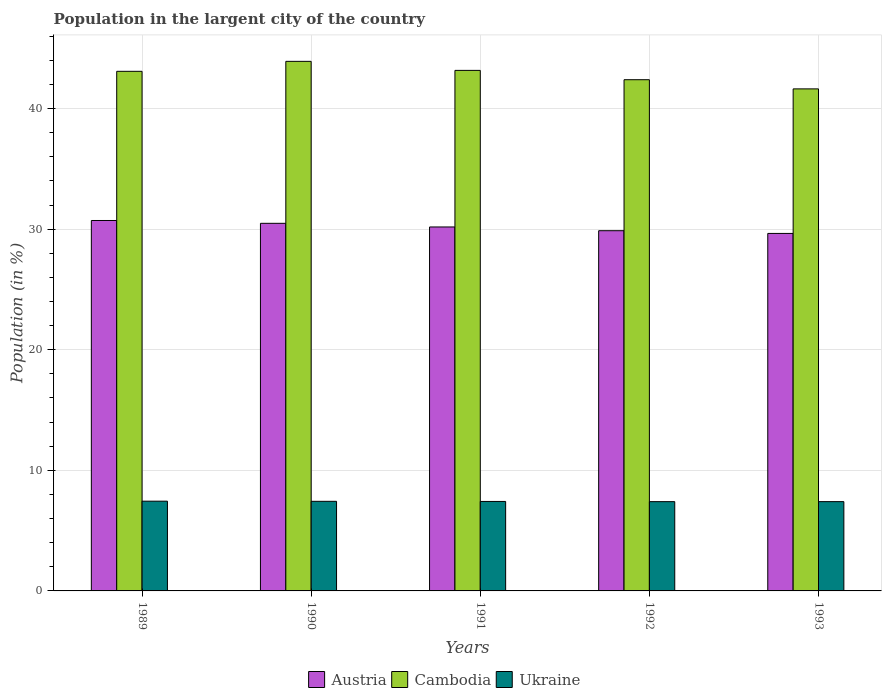How many different coloured bars are there?
Offer a very short reply. 3. Are the number of bars per tick equal to the number of legend labels?
Your answer should be compact. Yes. How many bars are there on the 4th tick from the left?
Your response must be concise. 3. What is the label of the 5th group of bars from the left?
Provide a succinct answer. 1993. What is the percentage of population in the largent city in Austria in 1991?
Offer a terse response. 30.18. Across all years, what is the maximum percentage of population in the largent city in Ukraine?
Provide a short and direct response. 7.44. Across all years, what is the minimum percentage of population in the largent city in Ukraine?
Make the answer very short. 7.4. In which year was the percentage of population in the largent city in Austria maximum?
Give a very brief answer. 1989. What is the total percentage of population in the largent city in Cambodia in the graph?
Give a very brief answer. 214.18. What is the difference between the percentage of population in the largent city in Ukraine in 1990 and that in 1991?
Provide a succinct answer. 0.01. What is the difference between the percentage of population in the largent city in Ukraine in 1992 and the percentage of population in the largent city in Cambodia in 1993?
Give a very brief answer. -34.23. What is the average percentage of population in the largent city in Ukraine per year?
Ensure brevity in your answer.  7.42. In the year 1993, what is the difference between the percentage of population in the largent city in Ukraine and percentage of population in the largent city in Austria?
Your answer should be very brief. -22.24. What is the ratio of the percentage of population in the largent city in Austria in 1989 to that in 1993?
Provide a succinct answer. 1.04. Is the percentage of population in the largent city in Ukraine in 1989 less than that in 1990?
Keep it short and to the point. No. What is the difference between the highest and the second highest percentage of population in the largent city in Cambodia?
Offer a very short reply. 0.75. What is the difference between the highest and the lowest percentage of population in the largent city in Ukraine?
Your answer should be compact. 0.04. In how many years, is the percentage of population in the largent city in Cambodia greater than the average percentage of population in the largent city in Cambodia taken over all years?
Provide a short and direct response. 3. Is the sum of the percentage of population in the largent city in Austria in 1989 and 1992 greater than the maximum percentage of population in the largent city in Ukraine across all years?
Keep it short and to the point. Yes. What does the 2nd bar from the left in 1989 represents?
Provide a succinct answer. Cambodia. What does the 3rd bar from the right in 1989 represents?
Provide a succinct answer. Austria. How many bars are there?
Give a very brief answer. 15. How many years are there in the graph?
Ensure brevity in your answer.  5. Does the graph contain any zero values?
Offer a terse response. No. Where does the legend appear in the graph?
Offer a terse response. Bottom center. How many legend labels are there?
Provide a short and direct response. 3. How are the legend labels stacked?
Provide a succinct answer. Horizontal. What is the title of the graph?
Provide a succinct answer. Population in the largent city of the country. Does "Canada" appear as one of the legend labels in the graph?
Your response must be concise. No. What is the label or title of the Y-axis?
Ensure brevity in your answer.  Population (in %). What is the Population (in %) in Austria in 1989?
Your answer should be very brief. 30.72. What is the Population (in %) of Cambodia in 1989?
Your answer should be very brief. 43.09. What is the Population (in %) in Ukraine in 1989?
Make the answer very short. 7.44. What is the Population (in %) in Austria in 1990?
Ensure brevity in your answer.  30.48. What is the Population (in %) of Cambodia in 1990?
Make the answer very short. 43.91. What is the Population (in %) in Ukraine in 1990?
Make the answer very short. 7.43. What is the Population (in %) of Austria in 1991?
Your answer should be compact. 30.18. What is the Population (in %) in Cambodia in 1991?
Your response must be concise. 43.16. What is the Population (in %) in Ukraine in 1991?
Give a very brief answer. 7.42. What is the Population (in %) in Austria in 1992?
Provide a short and direct response. 29.87. What is the Population (in %) of Cambodia in 1992?
Keep it short and to the point. 42.39. What is the Population (in %) of Ukraine in 1992?
Your response must be concise. 7.4. What is the Population (in %) in Austria in 1993?
Keep it short and to the point. 29.64. What is the Population (in %) of Cambodia in 1993?
Your response must be concise. 41.63. What is the Population (in %) in Ukraine in 1993?
Your response must be concise. 7.4. Across all years, what is the maximum Population (in %) of Austria?
Give a very brief answer. 30.72. Across all years, what is the maximum Population (in %) of Cambodia?
Provide a short and direct response. 43.91. Across all years, what is the maximum Population (in %) of Ukraine?
Offer a terse response. 7.44. Across all years, what is the minimum Population (in %) in Austria?
Offer a very short reply. 29.64. Across all years, what is the minimum Population (in %) in Cambodia?
Provide a succinct answer. 41.63. Across all years, what is the minimum Population (in %) of Ukraine?
Your response must be concise. 7.4. What is the total Population (in %) of Austria in the graph?
Offer a very short reply. 150.89. What is the total Population (in %) of Cambodia in the graph?
Provide a succinct answer. 214.18. What is the total Population (in %) of Ukraine in the graph?
Give a very brief answer. 37.1. What is the difference between the Population (in %) in Austria in 1989 and that in 1990?
Offer a very short reply. 0.23. What is the difference between the Population (in %) in Cambodia in 1989 and that in 1990?
Provide a short and direct response. -0.83. What is the difference between the Population (in %) in Ukraine in 1989 and that in 1990?
Offer a terse response. 0.01. What is the difference between the Population (in %) of Austria in 1989 and that in 1991?
Provide a succinct answer. 0.54. What is the difference between the Population (in %) of Cambodia in 1989 and that in 1991?
Your answer should be compact. -0.08. What is the difference between the Population (in %) of Ukraine in 1989 and that in 1991?
Keep it short and to the point. 0.02. What is the difference between the Population (in %) of Austria in 1989 and that in 1992?
Ensure brevity in your answer.  0.85. What is the difference between the Population (in %) of Cambodia in 1989 and that in 1992?
Give a very brief answer. 0.7. What is the difference between the Population (in %) of Ukraine in 1989 and that in 1992?
Keep it short and to the point. 0.04. What is the difference between the Population (in %) of Austria in 1989 and that in 1993?
Make the answer very short. 1.07. What is the difference between the Population (in %) in Cambodia in 1989 and that in 1993?
Keep it short and to the point. 1.46. What is the difference between the Population (in %) of Ukraine in 1989 and that in 1993?
Ensure brevity in your answer.  0.04. What is the difference between the Population (in %) in Austria in 1990 and that in 1991?
Give a very brief answer. 0.3. What is the difference between the Population (in %) in Cambodia in 1990 and that in 1991?
Ensure brevity in your answer.  0.75. What is the difference between the Population (in %) of Ukraine in 1990 and that in 1991?
Give a very brief answer. 0.01. What is the difference between the Population (in %) in Austria in 1990 and that in 1992?
Offer a very short reply. 0.61. What is the difference between the Population (in %) in Cambodia in 1990 and that in 1992?
Your answer should be very brief. 1.52. What is the difference between the Population (in %) of Ukraine in 1990 and that in 1992?
Provide a succinct answer. 0.03. What is the difference between the Population (in %) of Austria in 1990 and that in 1993?
Offer a very short reply. 0.84. What is the difference between the Population (in %) of Cambodia in 1990 and that in 1993?
Your response must be concise. 2.28. What is the difference between the Population (in %) in Ukraine in 1990 and that in 1993?
Your answer should be very brief. 0.03. What is the difference between the Population (in %) in Austria in 1991 and that in 1992?
Make the answer very short. 0.31. What is the difference between the Population (in %) in Cambodia in 1991 and that in 1992?
Ensure brevity in your answer.  0.77. What is the difference between the Population (in %) in Ukraine in 1991 and that in 1992?
Offer a very short reply. 0.02. What is the difference between the Population (in %) in Austria in 1991 and that in 1993?
Provide a short and direct response. 0.54. What is the difference between the Population (in %) of Cambodia in 1991 and that in 1993?
Provide a short and direct response. 1.53. What is the difference between the Population (in %) in Ukraine in 1991 and that in 1993?
Your answer should be compact. 0.02. What is the difference between the Population (in %) of Austria in 1992 and that in 1993?
Offer a terse response. 0.23. What is the difference between the Population (in %) in Cambodia in 1992 and that in 1993?
Provide a succinct answer. 0.76. What is the difference between the Population (in %) of Ukraine in 1992 and that in 1993?
Make the answer very short. -0. What is the difference between the Population (in %) in Austria in 1989 and the Population (in %) in Cambodia in 1990?
Make the answer very short. -13.2. What is the difference between the Population (in %) in Austria in 1989 and the Population (in %) in Ukraine in 1990?
Keep it short and to the point. 23.29. What is the difference between the Population (in %) of Cambodia in 1989 and the Population (in %) of Ukraine in 1990?
Offer a terse response. 35.66. What is the difference between the Population (in %) of Austria in 1989 and the Population (in %) of Cambodia in 1991?
Provide a succinct answer. -12.45. What is the difference between the Population (in %) in Austria in 1989 and the Population (in %) in Ukraine in 1991?
Provide a succinct answer. 23.3. What is the difference between the Population (in %) in Cambodia in 1989 and the Population (in %) in Ukraine in 1991?
Ensure brevity in your answer.  35.67. What is the difference between the Population (in %) of Austria in 1989 and the Population (in %) of Cambodia in 1992?
Ensure brevity in your answer.  -11.67. What is the difference between the Population (in %) in Austria in 1989 and the Population (in %) in Ukraine in 1992?
Your answer should be compact. 23.31. What is the difference between the Population (in %) in Cambodia in 1989 and the Population (in %) in Ukraine in 1992?
Offer a terse response. 35.68. What is the difference between the Population (in %) of Austria in 1989 and the Population (in %) of Cambodia in 1993?
Your response must be concise. -10.91. What is the difference between the Population (in %) in Austria in 1989 and the Population (in %) in Ukraine in 1993?
Offer a terse response. 23.31. What is the difference between the Population (in %) of Cambodia in 1989 and the Population (in %) of Ukraine in 1993?
Offer a very short reply. 35.68. What is the difference between the Population (in %) of Austria in 1990 and the Population (in %) of Cambodia in 1991?
Give a very brief answer. -12.68. What is the difference between the Population (in %) in Austria in 1990 and the Population (in %) in Ukraine in 1991?
Provide a short and direct response. 23.06. What is the difference between the Population (in %) of Cambodia in 1990 and the Population (in %) of Ukraine in 1991?
Provide a succinct answer. 36.49. What is the difference between the Population (in %) of Austria in 1990 and the Population (in %) of Cambodia in 1992?
Your answer should be compact. -11.91. What is the difference between the Population (in %) of Austria in 1990 and the Population (in %) of Ukraine in 1992?
Keep it short and to the point. 23.08. What is the difference between the Population (in %) in Cambodia in 1990 and the Population (in %) in Ukraine in 1992?
Offer a very short reply. 36.51. What is the difference between the Population (in %) in Austria in 1990 and the Population (in %) in Cambodia in 1993?
Your answer should be very brief. -11.15. What is the difference between the Population (in %) in Austria in 1990 and the Population (in %) in Ukraine in 1993?
Ensure brevity in your answer.  23.08. What is the difference between the Population (in %) of Cambodia in 1990 and the Population (in %) of Ukraine in 1993?
Make the answer very short. 36.51. What is the difference between the Population (in %) of Austria in 1991 and the Population (in %) of Cambodia in 1992?
Keep it short and to the point. -12.21. What is the difference between the Population (in %) in Austria in 1991 and the Population (in %) in Ukraine in 1992?
Provide a short and direct response. 22.78. What is the difference between the Population (in %) in Cambodia in 1991 and the Population (in %) in Ukraine in 1992?
Provide a short and direct response. 35.76. What is the difference between the Population (in %) in Austria in 1991 and the Population (in %) in Cambodia in 1993?
Make the answer very short. -11.45. What is the difference between the Population (in %) in Austria in 1991 and the Population (in %) in Ukraine in 1993?
Ensure brevity in your answer.  22.78. What is the difference between the Population (in %) of Cambodia in 1991 and the Population (in %) of Ukraine in 1993?
Keep it short and to the point. 35.76. What is the difference between the Population (in %) in Austria in 1992 and the Population (in %) in Cambodia in 1993?
Your answer should be very brief. -11.76. What is the difference between the Population (in %) in Austria in 1992 and the Population (in %) in Ukraine in 1993?
Your answer should be very brief. 22.47. What is the difference between the Population (in %) in Cambodia in 1992 and the Population (in %) in Ukraine in 1993?
Your response must be concise. 34.99. What is the average Population (in %) in Austria per year?
Provide a succinct answer. 30.18. What is the average Population (in %) of Cambodia per year?
Give a very brief answer. 42.84. What is the average Population (in %) in Ukraine per year?
Provide a short and direct response. 7.42. In the year 1989, what is the difference between the Population (in %) in Austria and Population (in %) in Cambodia?
Your answer should be very brief. -12.37. In the year 1989, what is the difference between the Population (in %) in Austria and Population (in %) in Ukraine?
Ensure brevity in your answer.  23.27. In the year 1989, what is the difference between the Population (in %) of Cambodia and Population (in %) of Ukraine?
Give a very brief answer. 35.64. In the year 1990, what is the difference between the Population (in %) in Austria and Population (in %) in Cambodia?
Make the answer very short. -13.43. In the year 1990, what is the difference between the Population (in %) in Austria and Population (in %) in Ukraine?
Your response must be concise. 23.05. In the year 1990, what is the difference between the Population (in %) of Cambodia and Population (in %) of Ukraine?
Provide a succinct answer. 36.48. In the year 1991, what is the difference between the Population (in %) of Austria and Population (in %) of Cambodia?
Keep it short and to the point. -12.98. In the year 1991, what is the difference between the Population (in %) in Austria and Population (in %) in Ukraine?
Offer a terse response. 22.76. In the year 1991, what is the difference between the Population (in %) in Cambodia and Population (in %) in Ukraine?
Provide a succinct answer. 35.74. In the year 1992, what is the difference between the Population (in %) of Austria and Population (in %) of Cambodia?
Provide a short and direct response. -12.52. In the year 1992, what is the difference between the Population (in %) of Austria and Population (in %) of Ukraine?
Give a very brief answer. 22.47. In the year 1992, what is the difference between the Population (in %) of Cambodia and Population (in %) of Ukraine?
Keep it short and to the point. 34.99. In the year 1993, what is the difference between the Population (in %) in Austria and Population (in %) in Cambodia?
Your answer should be compact. -11.99. In the year 1993, what is the difference between the Population (in %) in Austria and Population (in %) in Ukraine?
Keep it short and to the point. 22.24. In the year 1993, what is the difference between the Population (in %) in Cambodia and Population (in %) in Ukraine?
Your answer should be compact. 34.23. What is the ratio of the Population (in %) of Austria in 1989 to that in 1990?
Your answer should be compact. 1.01. What is the ratio of the Population (in %) in Cambodia in 1989 to that in 1990?
Keep it short and to the point. 0.98. What is the ratio of the Population (in %) of Austria in 1989 to that in 1991?
Provide a short and direct response. 1.02. What is the ratio of the Population (in %) of Ukraine in 1989 to that in 1991?
Offer a very short reply. 1. What is the ratio of the Population (in %) of Austria in 1989 to that in 1992?
Provide a succinct answer. 1.03. What is the ratio of the Population (in %) in Cambodia in 1989 to that in 1992?
Keep it short and to the point. 1.02. What is the ratio of the Population (in %) in Ukraine in 1989 to that in 1992?
Your response must be concise. 1.01. What is the ratio of the Population (in %) in Austria in 1989 to that in 1993?
Your response must be concise. 1.04. What is the ratio of the Population (in %) in Cambodia in 1989 to that in 1993?
Offer a very short reply. 1.03. What is the ratio of the Population (in %) of Ukraine in 1989 to that in 1993?
Provide a succinct answer. 1.01. What is the ratio of the Population (in %) in Cambodia in 1990 to that in 1991?
Your response must be concise. 1.02. What is the ratio of the Population (in %) in Ukraine in 1990 to that in 1991?
Ensure brevity in your answer.  1. What is the ratio of the Population (in %) in Austria in 1990 to that in 1992?
Make the answer very short. 1.02. What is the ratio of the Population (in %) of Cambodia in 1990 to that in 1992?
Your response must be concise. 1.04. What is the ratio of the Population (in %) of Austria in 1990 to that in 1993?
Keep it short and to the point. 1.03. What is the ratio of the Population (in %) of Cambodia in 1990 to that in 1993?
Your answer should be very brief. 1.05. What is the ratio of the Population (in %) of Austria in 1991 to that in 1992?
Your response must be concise. 1.01. What is the ratio of the Population (in %) in Cambodia in 1991 to that in 1992?
Offer a terse response. 1.02. What is the ratio of the Population (in %) of Ukraine in 1991 to that in 1992?
Offer a very short reply. 1. What is the ratio of the Population (in %) in Austria in 1991 to that in 1993?
Your answer should be compact. 1.02. What is the ratio of the Population (in %) in Cambodia in 1991 to that in 1993?
Provide a short and direct response. 1.04. What is the ratio of the Population (in %) of Austria in 1992 to that in 1993?
Give a very brief answer. 1.01. What is the ratio of the Population (in %) in Cambodia in 1992 to that in 1993?
Your answer should be compact. 1.02. What is the difference between the highest and the second highest Population (in %) of Austria?
Your response must be concise. 0.23. What is the difference between the highest and the second highest Population (in %) in Cambodia?
Offer a very short reply. 0.75. What is the difference between the highest and the second highest Population (in %) of Ukraine?
Your response must be concise. 0.01. What is the difference between the highest and the lowest Population (in %) of Austria?
Provide a succinct answer. 1.07. What is the difference between the highest and the lowest Population (in %) of Cambodia?
Provide a short and direct response. 2.28. What is the difference between the highest and the lowest Population (in %) in Ukraine?
Provide a short and direct response. 0.04. 